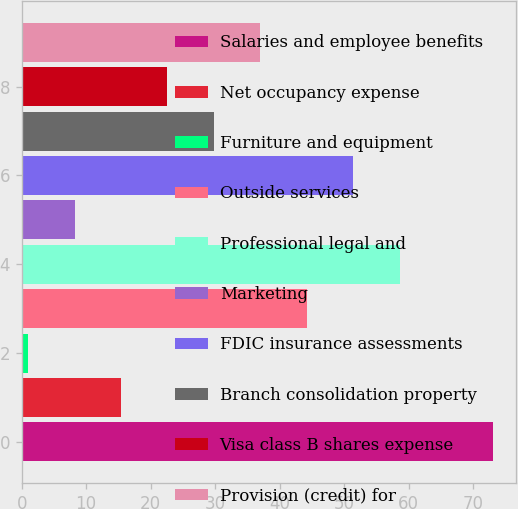Convert chart. <chart><loc_0><loc_0><loc_500><loc_500><bar_chart><fcel>Salaries and employee benefits<fcel>Net occupancy expense<fcel>Furniture and equipment<fcel>Outside services<fcel>Professional legal and<fcel>Marketing<fcel>FDIC insurance assessments<fcel>Branch consolidation property<fcel>Visa class B shares expense<fcel>Provision (credit) for<nl><fcel>73<fcel>15.4<fcel>1<fcel>44.2<fcel>58.6<fcel>8.2<fcel>51.4<fcel>29.8<fcel>22.6<fcel>37<nl></chart> 